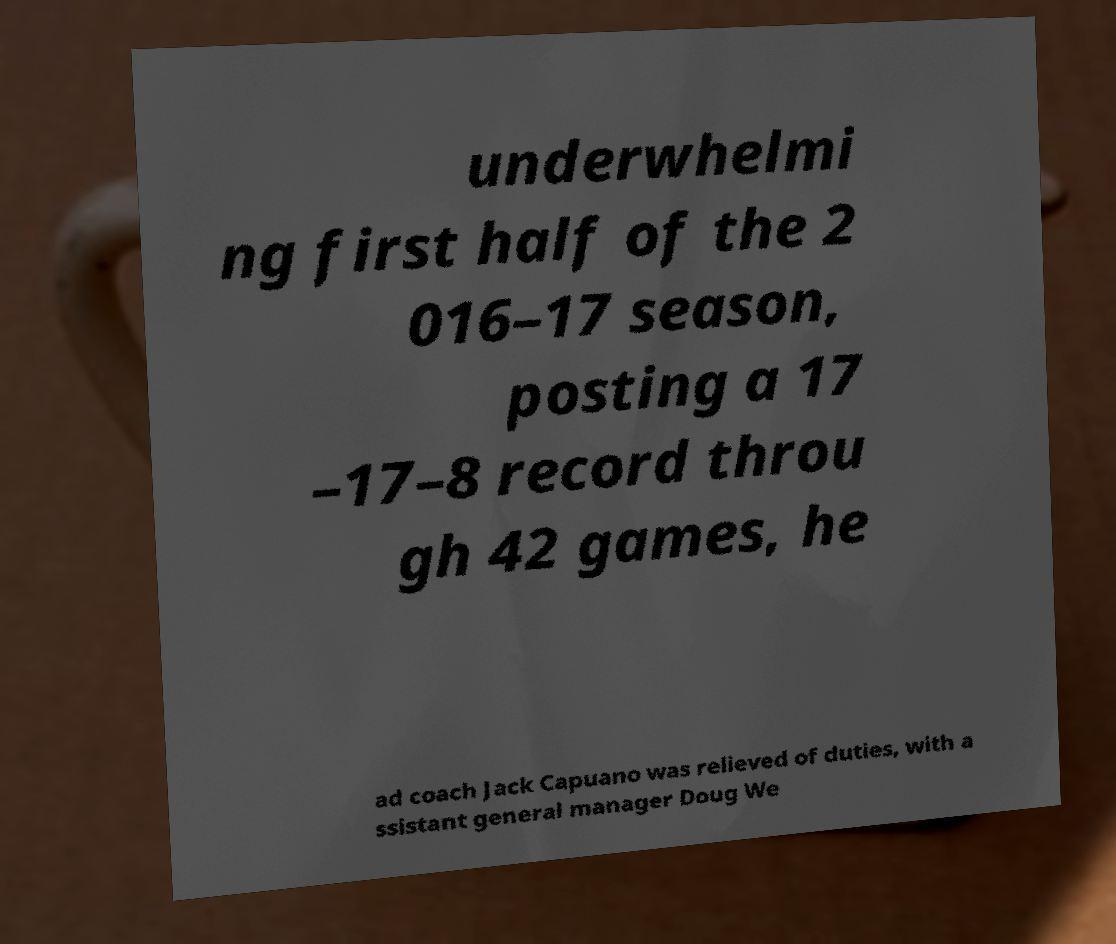Can you accurately transcribe the text from the provided image for me? underwhelmi ng first half of the 2 016–17 season, posting a 17 –17–8 record throu gh 42 games, he ad coach Jack Capuano was relieved of duties, with a ssistant general manager Doug We 